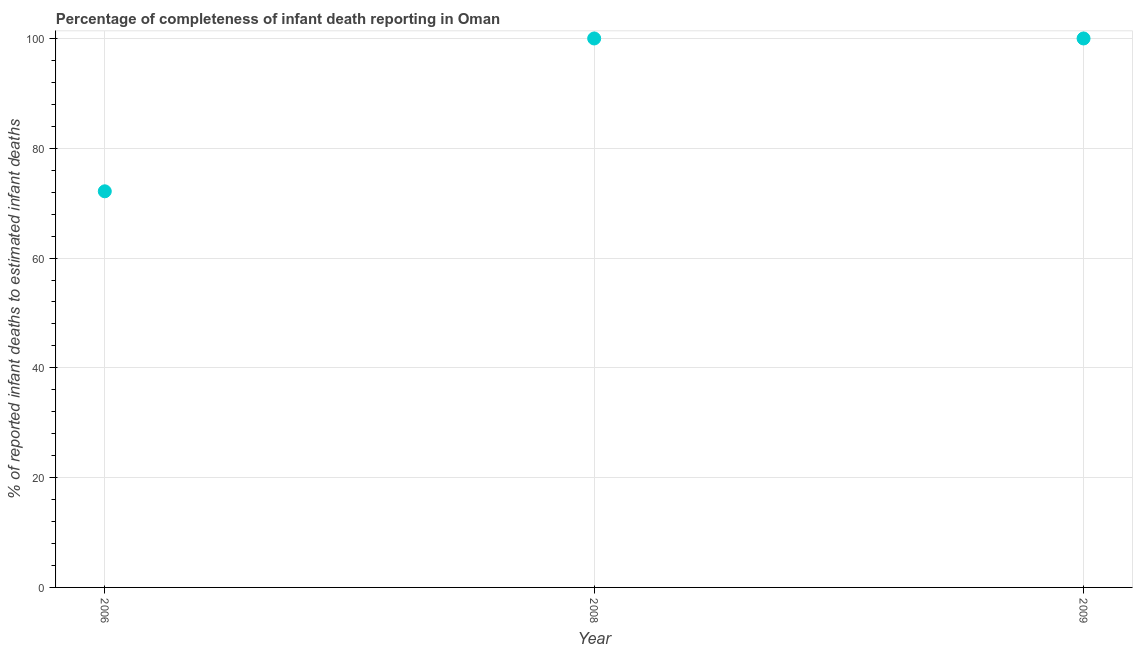What is the completeness of infant death reporting in 2006?
Keep it short and to the point. 72.16. Across all years, what is the minimum completeness of infant death reporting?
Keep it short and to the point. 72.16. What is the sum of the completeness of infant death reporting?
Provide a succinct answer. 272.16. What is the difference between the completeness of infant death reporting in 2006 and 2008?
Keep it short and to the point. -27.84. What is the average completeness of infant death reporting per year?
Your answer should be very brief. 90.72. In how many years, is the completeness of infant death reporting greater than 80 %?
Offer a very short reply. 2. What is the ratio of the completeness of infant death reporting in 2008 to that in 2009?
Offer a terse response. 1. Is the completeness of infant death reporting in 2008 less than that in 2009?
Give a very brief answer. No. Is the difference between the completeness of infant death reporting in 2006 and 2009 greater than the difference between any two years?
Keep it short and to the point. Yes. What is the difference between the highest and the lowest completeness of infant death reporting?
Offer a terse response. 27.84. In how many years, is the completeness of infant death reporting greater than the average completeness of infant death reporting taken over all years?
Your answer should be compact. 2. How many dotlines are there?
Give a very brief answer. 1. Are the values on the major ticks of Y-axis written in scientific E-notation?
Offer a terse response. No. Does the graph contain any zero values?
Make the answer very short. No. Does the graph contain grids?
Offer a very short reply. Yes. What is the title of the graph?
Give a very brief answer. Percentage of completeness of infant death reporting in Oman. What is the label or title of the X-axis?
Ensure brevity in your answer.  Year. What is the label or title of the Y-axis?
Make the answer very short. % of reported infant deaths to estimated infant deaths. What is the % of reported infant deaths to estimated infant deaths in 2006?
Give a very brief answer. 72.16. What is the % of reported infant deaths to estimated infant deaths in 2008?
Your answer should be very brief. 100. What is the % of reported infant deaths to estimated infant deaths in 2009?
Keep it short and to the point. 100. What is the difference between the % of reported infant deaths to estimated infant deaths in 2006 and 2008?
Your answer should be very brief. -27.84. What is the difference between the % of reported infant deaths to estimated infant deaths in 2006 and 2009?
Offer a very short reply. -27.84. What is the difference between the % of reported infant deaths to estimated infant deaths in 2008 and 2009?
Offer a terse response. 0. What is the ratio of the % of reported infant deaths to estimated infant deaths in 2006 to that in 2008?
Your answer should be very brief. 0.72. What is the ratio of the % of reported infant deaths to estimated infant deaths in 2006 to that in 2009?
Offer a very short reply. 0.72. 